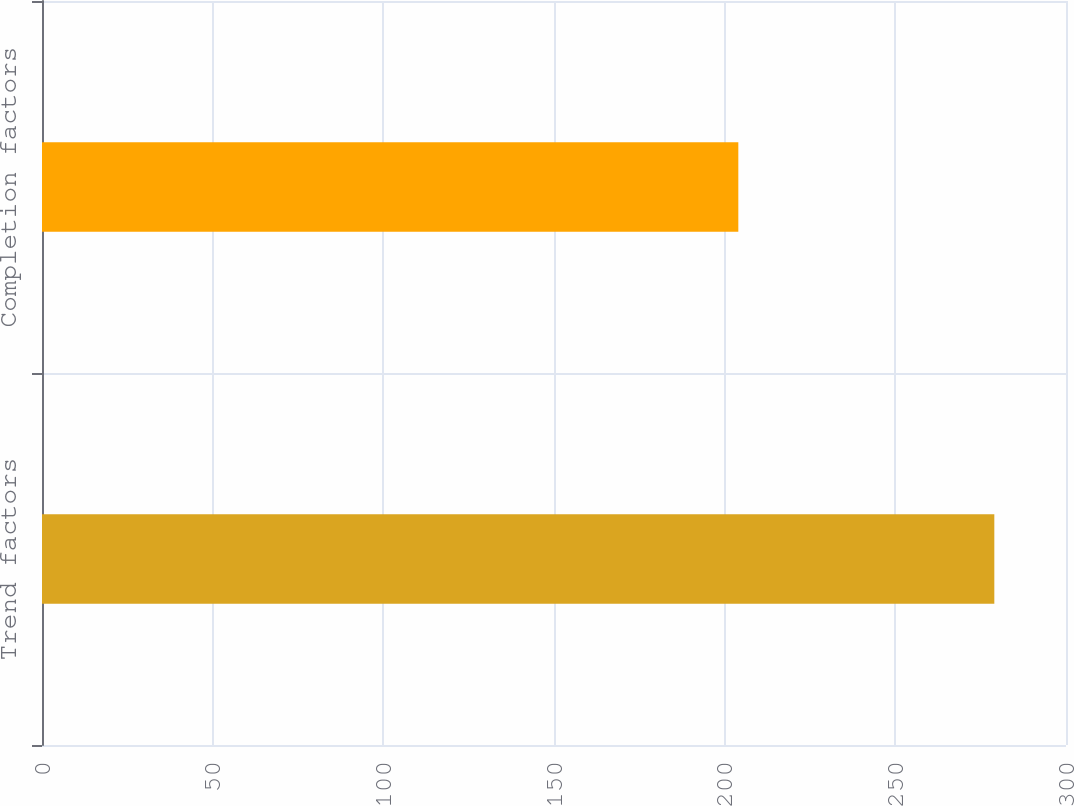Convert chart to OTSL. <chart><loc_0><loc_0><loc_500><loc_500><bar_chart><fcel>Trend factors<fcel>Completion factors<nl><fcel>279<fcel>204<nl></chart> 